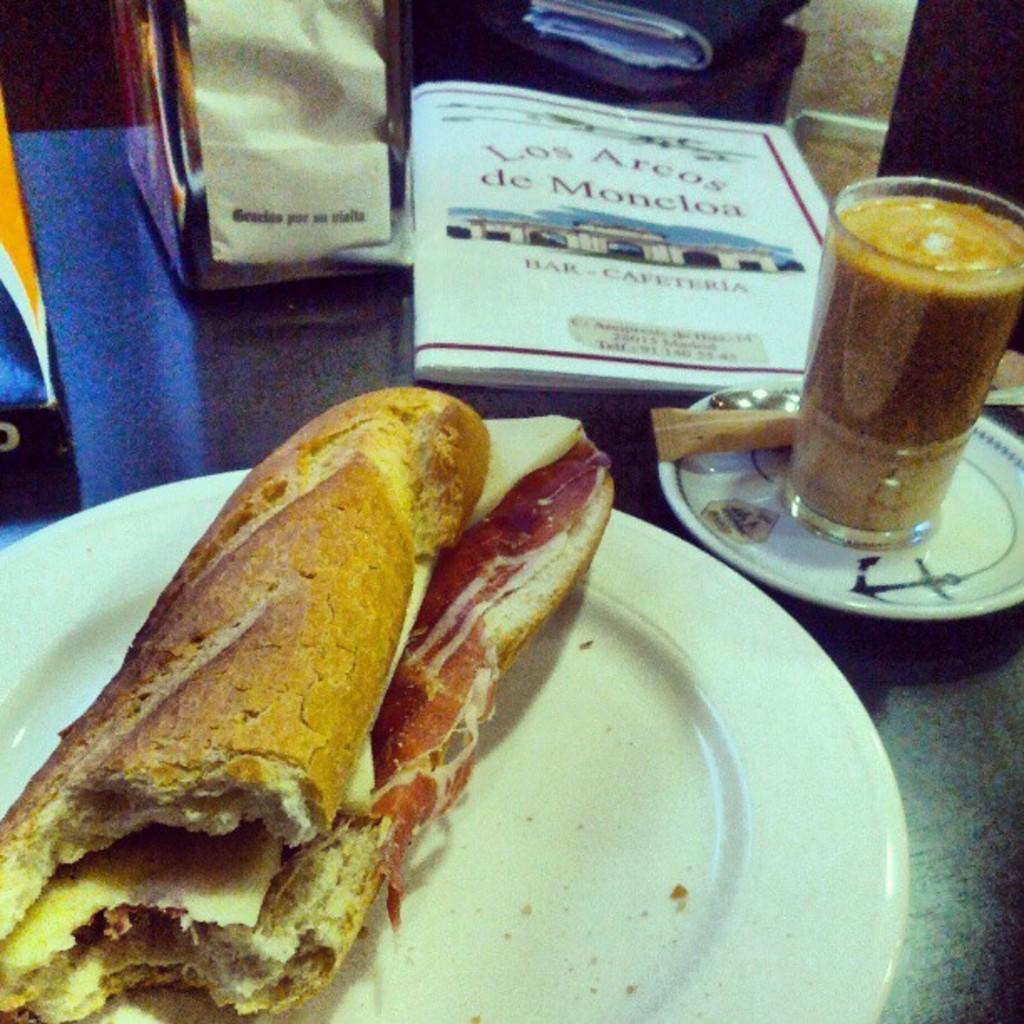What is the main food item served on a plate in the image? The specific food item is not mentioned, but there is a food item served on a plate in the image. What beverage is in the glass in the image? There is juice in the glass in the image. What object related to reading is present in the image? There is a book in the image. How many covers are visible in the image? There are two covers in the image. What type of riddle is being solved by the person in the image? There is no person or riddle present in the image. What kind of patch is being sewn onto the clothing in the image? There is no patch or clothing present in the image. 